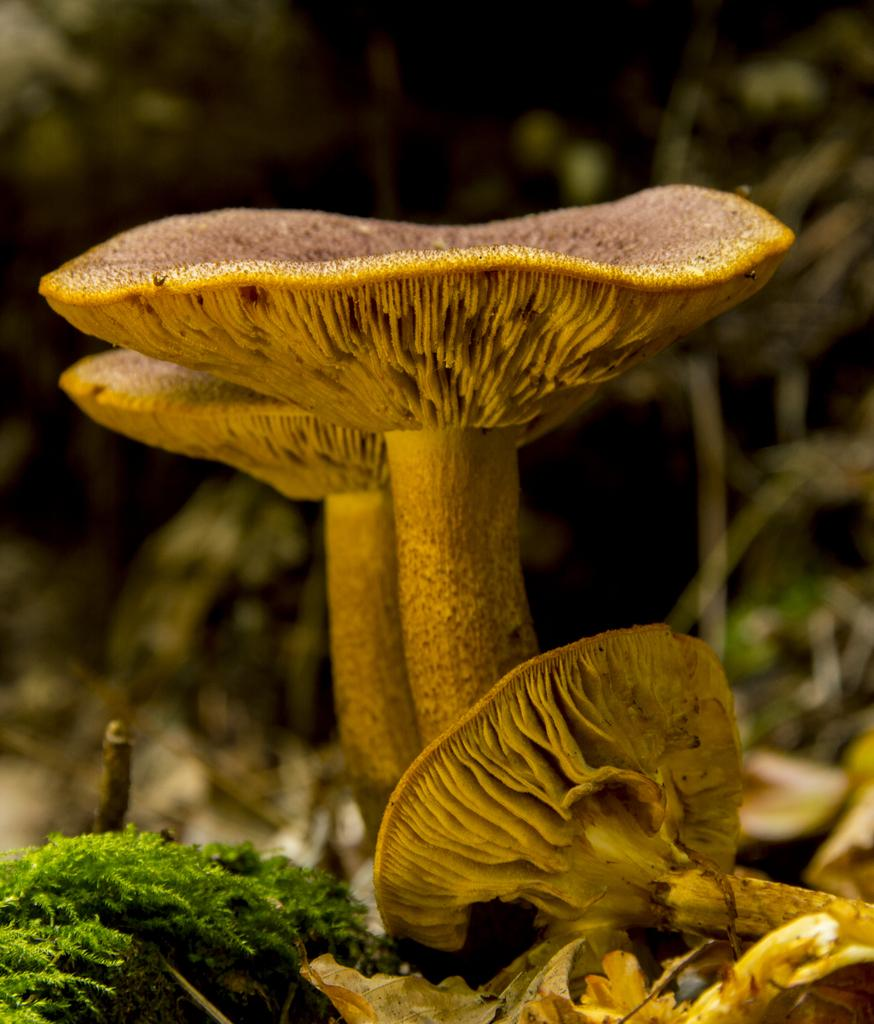What type of fungi can be seen in the image? There are mushrooms in the image. What other types of vegetation are present in the image? There are plants in the image. Can you describe the background of the image? The background of the image is blurry. How many members are on the team in the image? There is no team present in the image; it features mushrooms and plants. What type of lizards can be seen in the image? There are no lizards present in the image. 